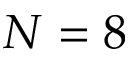Convert formula to latex. <formula><loc_0><loc_0><loc_500><loc_500>N = 8</formula> 